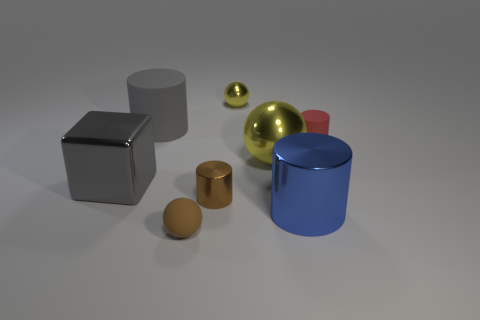Could you describe the lighting in this scene? The lighting in the image is subtle and appears to be ambient. There are no harsh shadows or overly bright highlights, indicating a diffuse light source that may be situated above and outside of the frame, creating a soft illumination over the objects. 